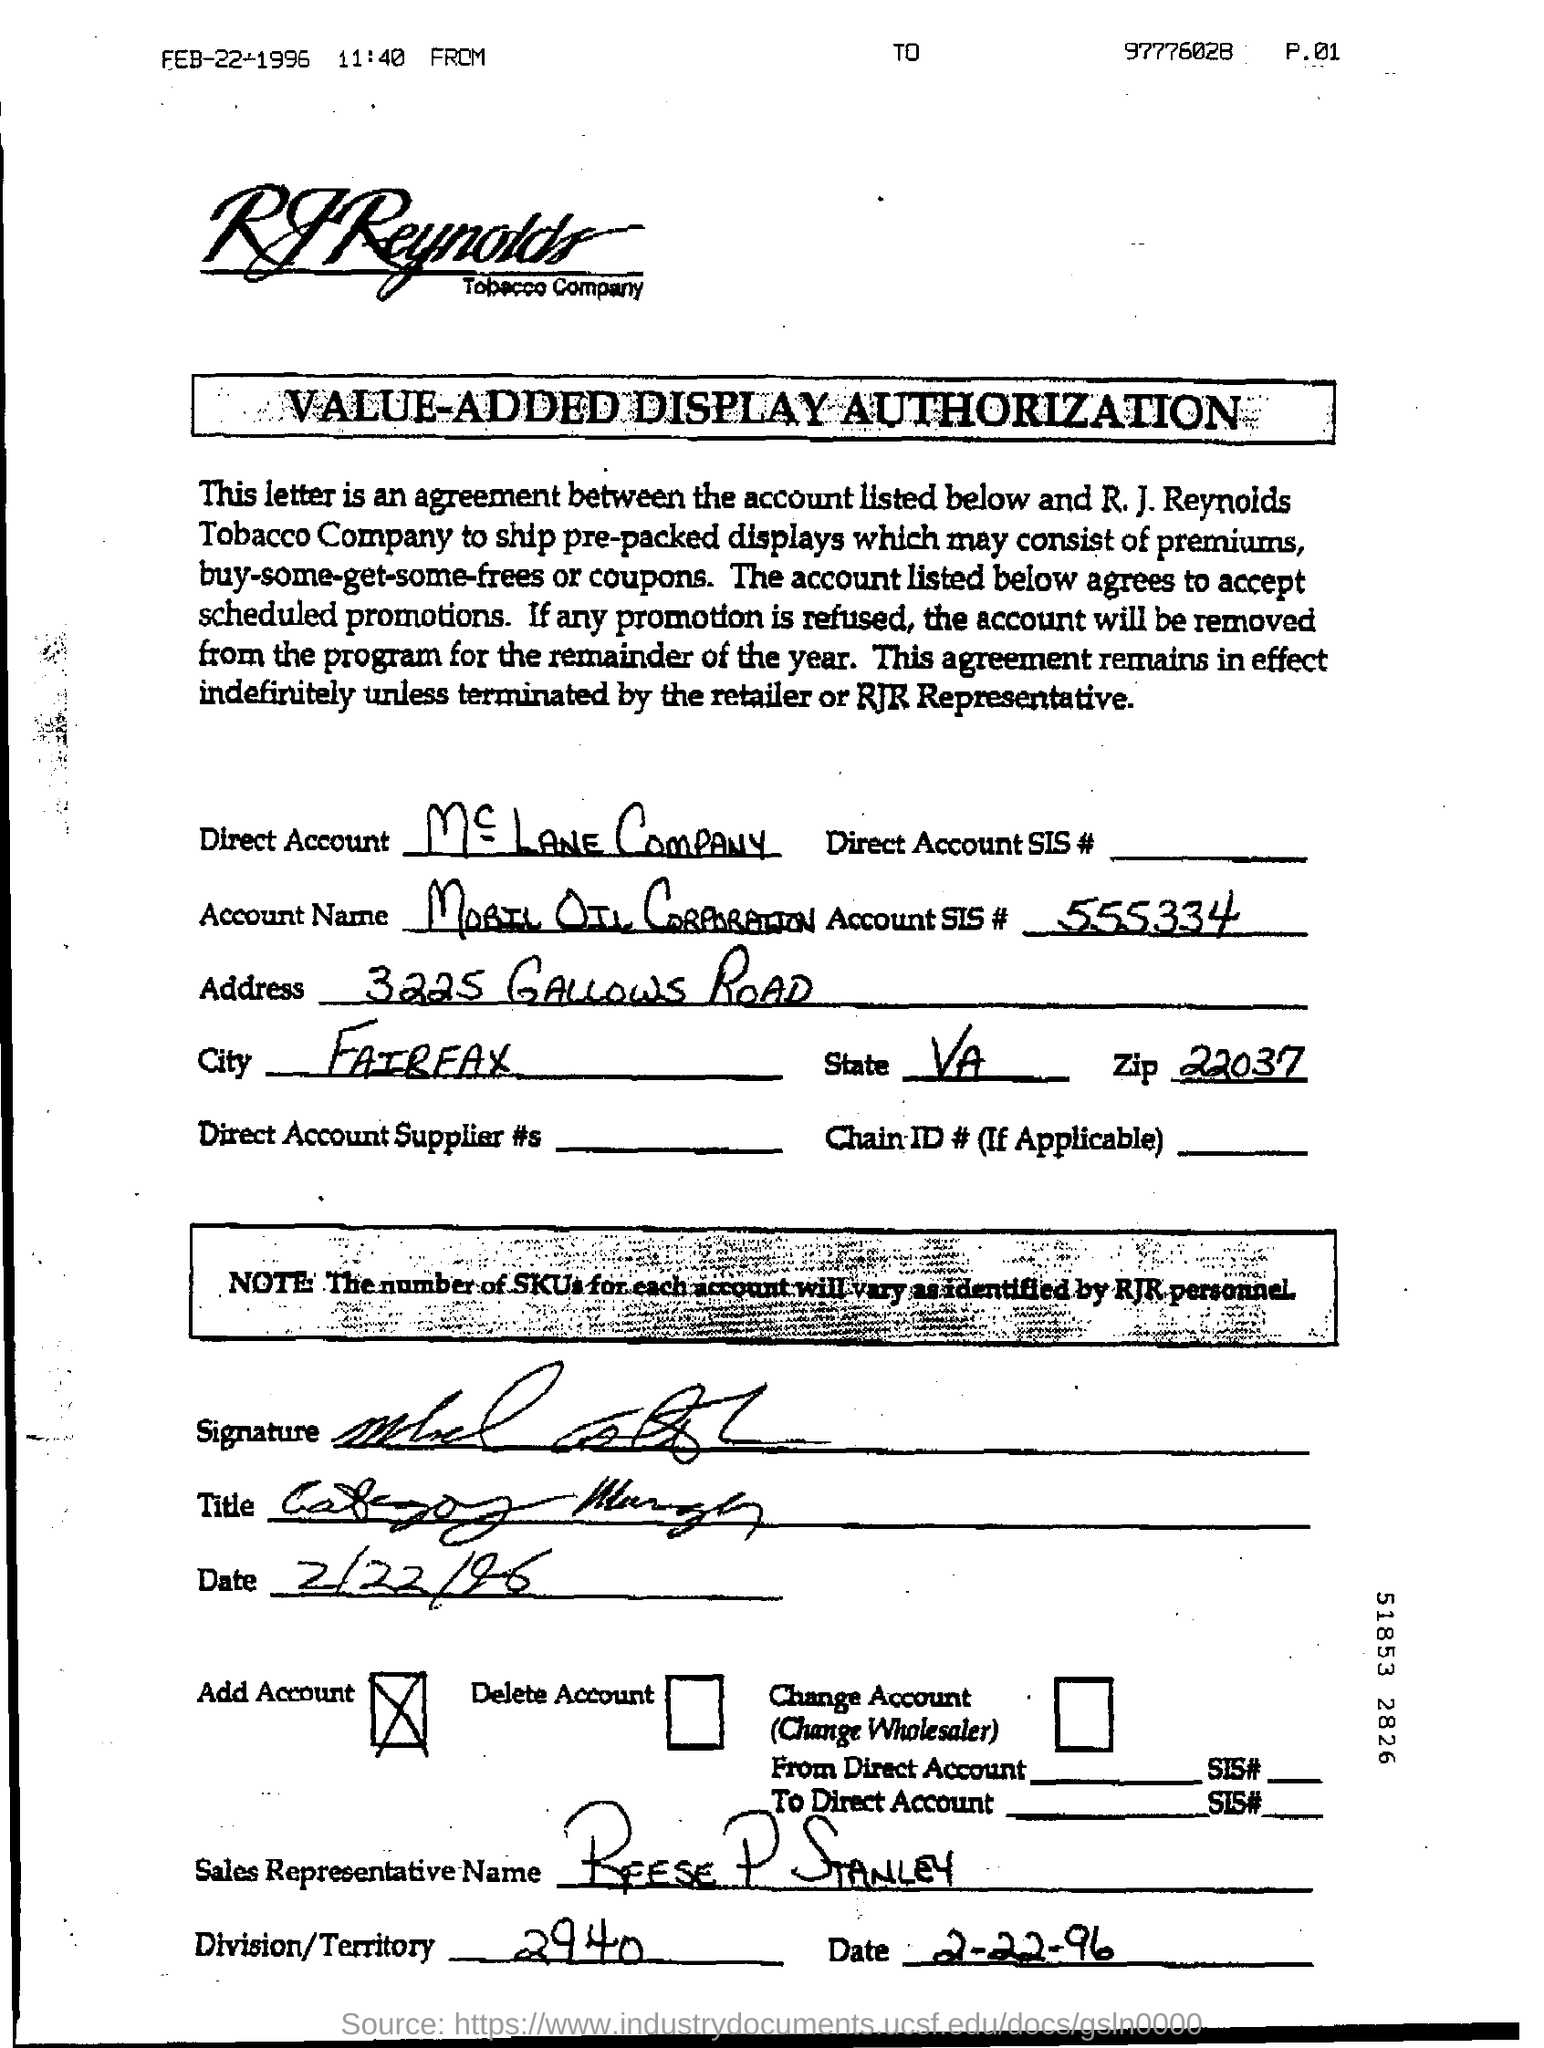Mention a couple of crucial points in this snapshot. The Account SIS number is 555334... The document indicates that the date is February 22, 1996. The account number mentioned in the document is SIS#555334... The zip code is 22037. The division/territory is 2940. 